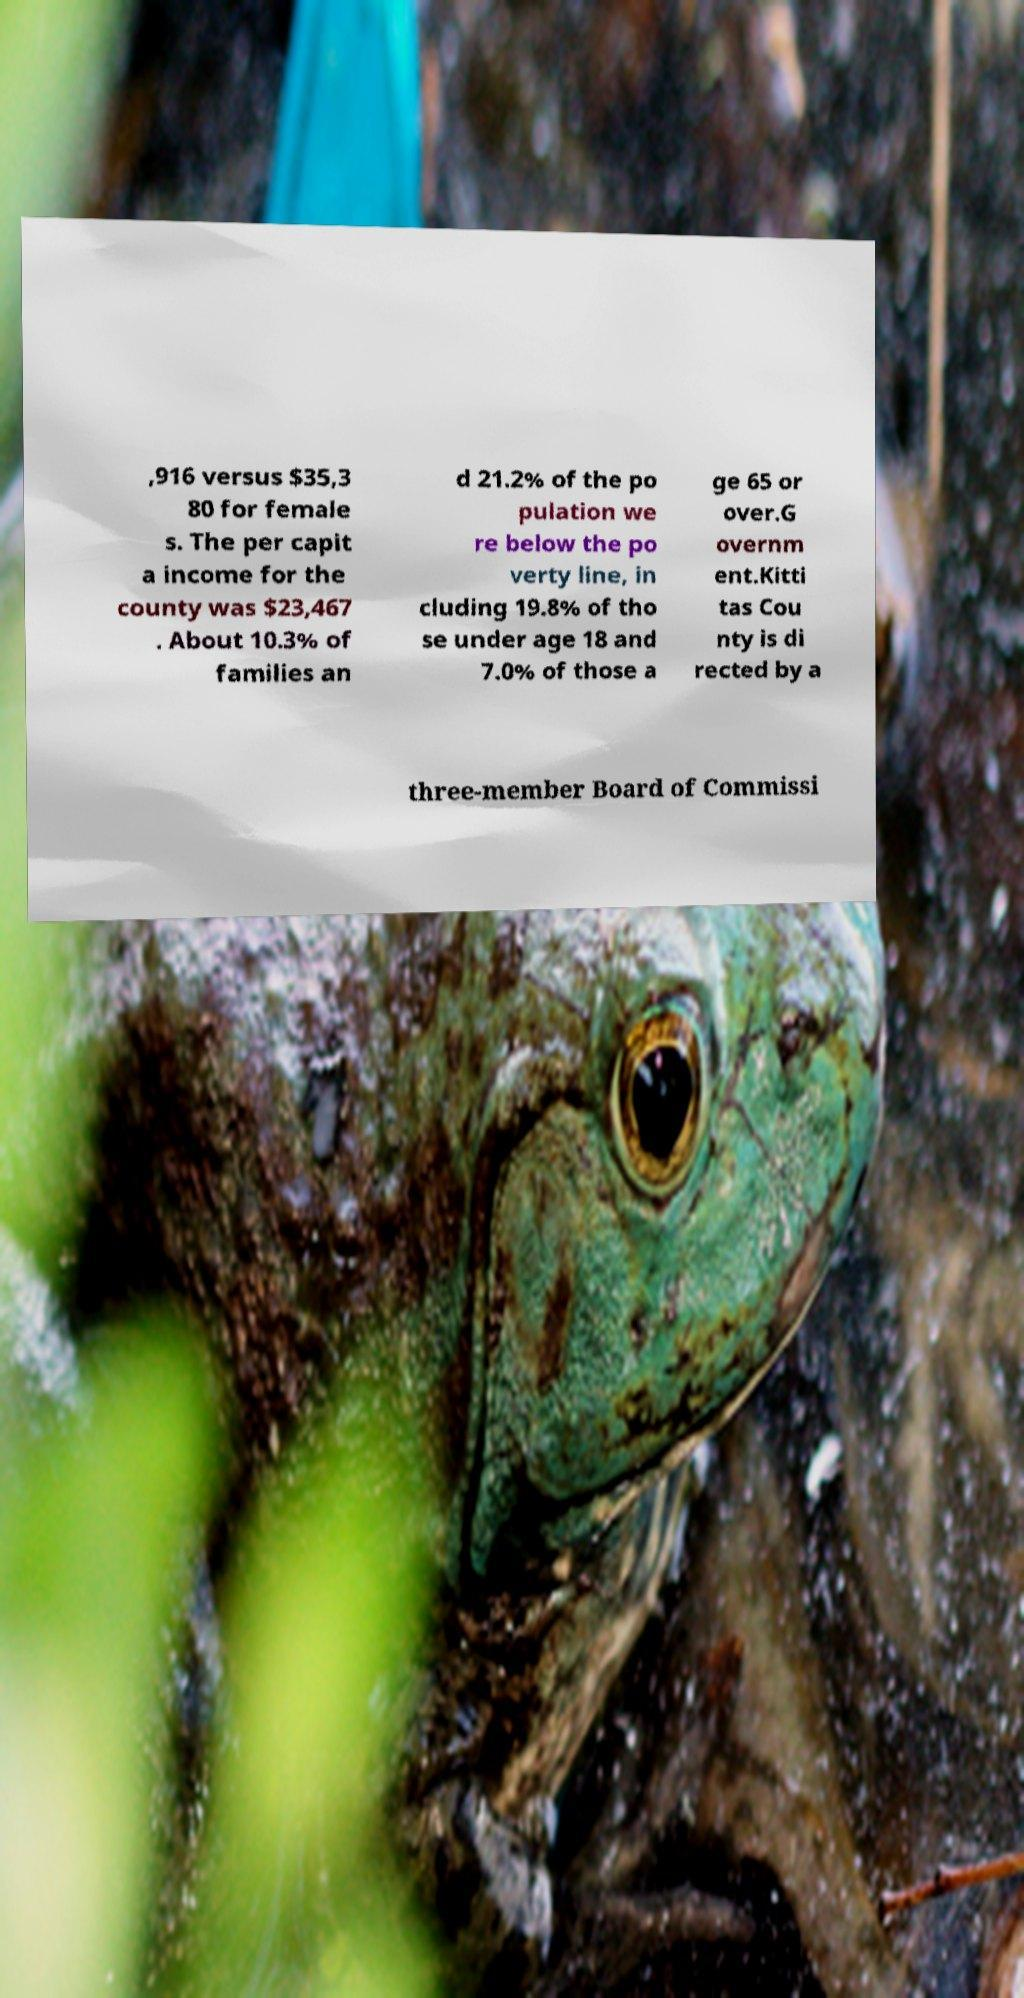Please identify and transcribe the text found in this image. ,916 versus $35,3 80 for female s. The per capit a income for the county was $23,467 . About 10.3% of families an d 21.2% of the po pulation we re below the po verty line, in cluding 19.8% of tho se under age 18 and 7.0% of those a ge 65 or over.G overnm ent.Kitti tas Cou nty is di rected by a three-member Board of Commissi 